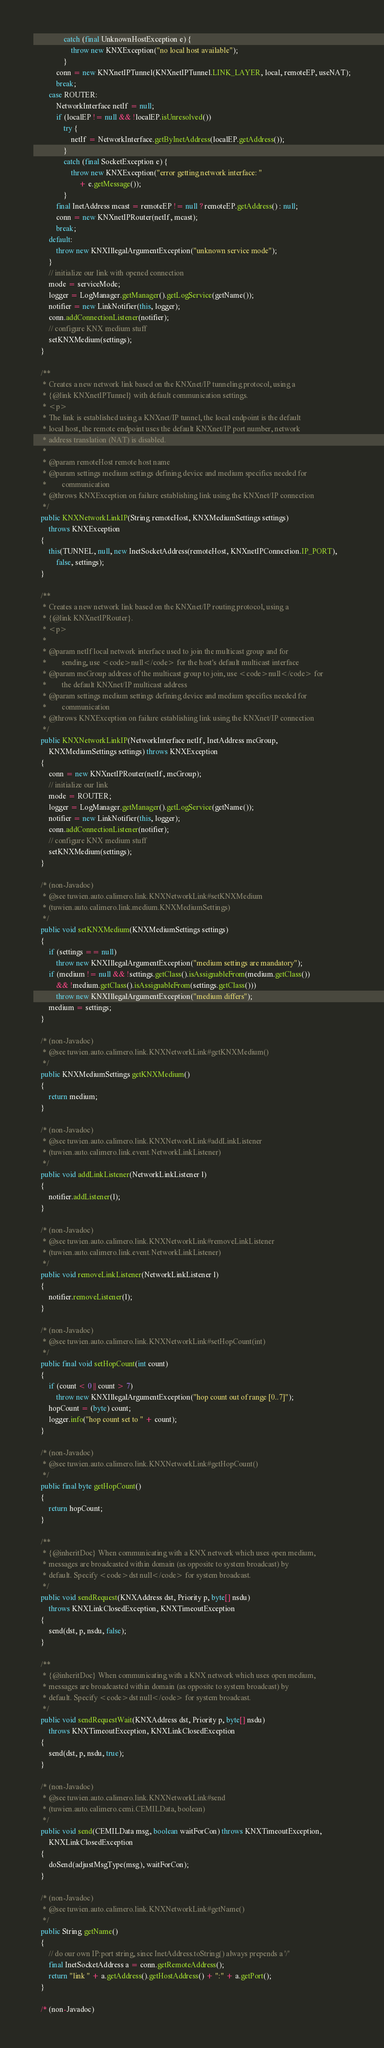<code> <loc_0><loc_0><loc_500><loc_500><_Java_>				catch (final UnknownHostException e) {
					throw new KNXException("no local host available");
				}
			conn = new KNXnetIPTunnel(KNXnetIPTunnel.LINK_LAYER, local, remoteEP, useNAT);
			break;
		case ROUTER:
			NetworkInterface netIf = null;
			if (localEP != null && !localEP.isUnresolved())
				try {
					netIf = NetworkInterface.getByInetAddress(localEP.getAddress());
				}
				catch (final SocketException e) {
					throw new KNXException("error getting network interface: "
						+ e.getMessage());
				}
			final InetAddress mcast = remoteEP != null ? remoteEP.getAddress() : null;
			conn = new KNXnetIPRouter(netIf, mcast);
			break;
		default:
			throw new KNXIllegalArgumentException("unknown service mode");
		}
		// initialize our link with opened connection
		mode = serviceMode;
		logger = LogManager.getManager().getLogService(getName());
		notifier = new LinkNotifier(this, logger);
		conn.addConnectionListener(notifier);
		// configure KNX medium stuff
		setKNXMedium(settings);
	}

	/**
	 * Creates a new network link based on the KNXnet/IP tunneling protocol, using a
	 * {@link KNXnetIPTunnel} with default communication settings.
	 * <p>
	 * The link is established using a KNXnet/IP tunnel, the local endpoint is the default
	 * local host, the remote endpoint uses the default KNXnet/IP port number, network
	 * address translation (NAT) is disabled.
	 * 
	 * @param remoteHost remote host name
	 * @param settings medium settings defining device and medium specifics needed for
	 *        communication
	 * @throws KNXException on failure establishing link using the KNXnet/IP connection
	 */
	public KNXNetworkLinkIP(String remoteHost, KNXMediumSettings settings)
		throws KNXException
	{
		this(TUNNEL, null, new InetSocketAddress(remoteHost, KNXnetIPConnection.IP_PORT),
			false, settings);
	}

	/**
	 * Creates a new network link based on the KNXnet/IP routing protocol, using a
	 * {@link KNXnetIPRouter}.
	 * <p>
	 * 
	 * @param netIf local network interface used to join the multicast group and for
	 *        sending, use <code>null</code> for the host's default multicast interface
	 * @param mcGroup address of the multicast group to join, use <code>null</code> for
	 *        the default KNXnet/IP multicast address
	 * @param settings medium settings defining device and medium specifics needed for
	 *        communication
	 * @throws KNXException on failure establishing link using the KNXnet/IP connection
	 */
	public KNXNetworkLinkIP(NetworkInterface netIf, InetAddress mcGroup,
		KNXMediumSettings settings) throws KNXException
	{
		conn = new KNXnetIPRouter(netIf, mcGroup);
		// initialize our link
		mode = ROUTER;
		logger = LogManager.getManager().getLogService(getName());
		notifier = new LinkNotifier(this, logger);
		conn.addConnectionListener(notifier);
		// configure KNX medium stuff
		setKNXMedium(settings);
	}

	/* (non-Javadoc)
	 * @see tuwien.auto.calimero.link.KNXNetworkLink#setKNXMedium
	 * (tuwien.auto.calimero.link.medium.KNXMediumSettings)
	 */
	public void setKNXMedium(KNXMediumSettings settings)
	{
		if (settings == null)
			throw new KNXIllegalArgumentException("medium settings are mandatory");
		if (medium != null && !settings.getClass().isAssignableFrom(medium.getClass())
			&& !medium.getClass().isAssignableFrom(settings.getClass()))
			throw new KNXIllegalArgumentException("medium differs");
		medium = settings;
	}

	/* (non-Javadoc)
	 * @see tuwien.auto.calimero.link.KNXNetworkLink#getKNXMedium()
	 */
	public KNXMediumSettings getKNXMedium()
	{
		return medium;
	}

	/* (non-Javadoc)
	 * @see tuwien.auto.calimero.link.KNXNetworkLink#addLinkListener
	 * (tuwien.auto.calimero.link.event.NetworkLinkListener)
	 */
	public void addLinkListener(NetworkLinkListener l)
	{
		notifier.addListener(l);
	}

	/* (non-Javadoc)
	 * @see tuwien.auto.calimero.link.KNXNetworkLink#removeLinkListener
	 * (tuwien.auto.calimero.link.event.NetworkLinkListener)
	 */
	public void removeLinkListener(NetworkLinkListener l)
	{
		notifier.removeListener(l);
	}

	/* (non-Javadoc)
	 * @see tuwien.auto.calimero.link.KNXNetworkLink#setHopCount(int)
	 */
	public final void setHopCount(int count)
	{
		if (count < 0 || count > 7)
			throw new KNXIllegalArgumentException("hop count out of range [0..7]");
		hopCount = (byte) count;
		logger.info("hop count set to " + count);
	}

	/* (non-Javadoc)
	 * @see tuwien.auto.calimero.link.KNXNetworkLink#getHopCount()
	 */
	public final byte getHopCount()
	{
		return hopCount;
	}

	/**
	 * {@inheritDoc} When communicating with a KNX network which uses open medium,
	 * messages are broadcasted within domain (as opposite to system broadcast) by
	 * default. Specify <code>dst null</code> for system broadcast.
	 */
	public void sendRequest(KNXAddress dst, Priority p, byte[] nsdu)
		throws KNXLinkClosedException, KNXTimeoutException
	{
		send(dst, p, nsdu, false);
	}

	/**
	 * {@inheritDoc} When communicating with a KNX network which uses open medium,
	 * messages are broadcasted within domain (as opposite to system broadcast) by
	 * default. Specify <code>dst null</code> for system broadcast.
	 */
	public void sendRequestWait(KNXAddress dst, Priority p, byte[] nsdu)
		throws KNXTimeoutException, KNXLinkClosedException
	{
		send(dst, p, nsdu, true);
	}

	/* (non-Javadoc)
	 * @see tuwien.auto.calimero.link.KNXNetworkLink#send
	 * (tuwien.auto.calimero.cemi.CEMILData, boolean)
	 */
	public void send(CEMILData msg, boolean waitForCon) throws KNXTimeoutException,
		KNXLinkClosedException
	{
		doSend(adjustMsgType(msg), waitForCon);
	}

	/* (non-Javadoc)
	 * @see tuwien.auto.calimero.link.KNXNetworkLink#getName()
	 */
	public String getName()
	{
		// do our own IP:port string, since InetAddress.toString() always prepends a '/'
		final InetSocketAddress a = conn.getRemoteAddress();
		return "link " + a.getAddress().getHostAddress() + ":" + a.getPort();
	}

	/* (non-Javadoc)</code> 